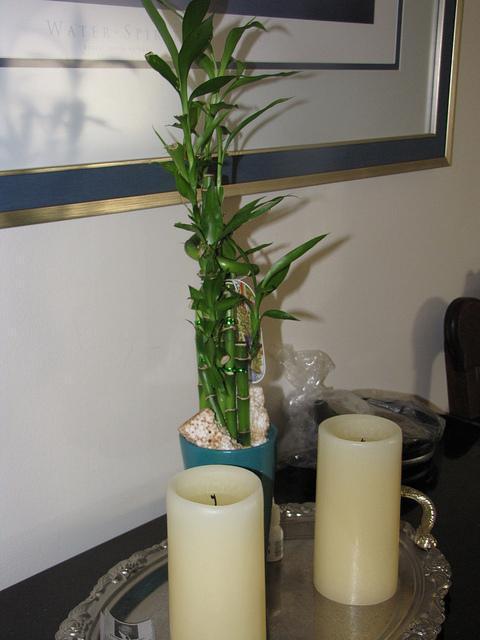How many candles are on the tray?
Give a very brief answer. 2. How many species of plants are shown?
Give a very brief answer. 1. How many people are there?
Give a very brief answer. 0. 